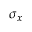<formula> <loc_0><loc_0><loc_500><loc_500>\sigma { _ { x } }</formula> 